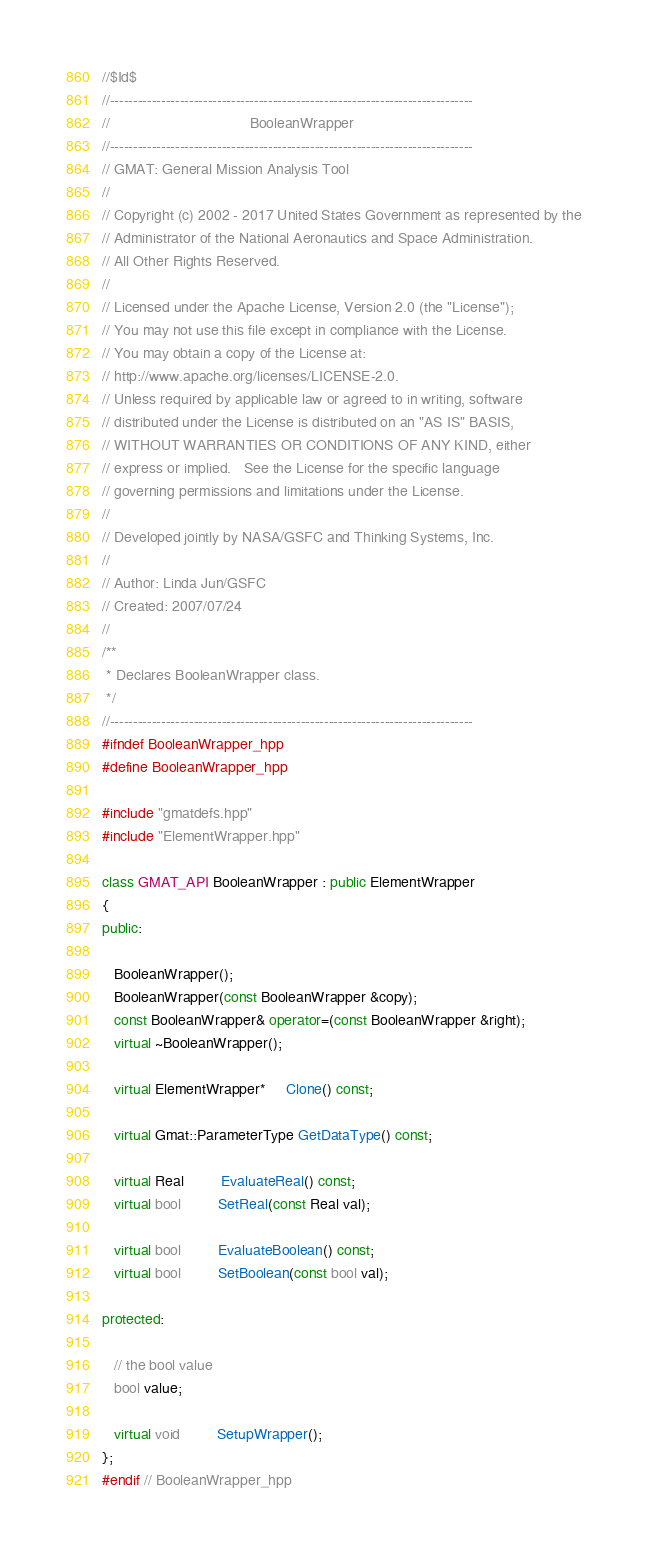Convert code to text. <code><loc_0><loc_0><loc_500><loc_500><_C++_>//$Id$
//------------------------------------------------------------------------------
//                                  BooleanWrapper
//------------------------------------------------------------------------------
// GMAT: General Mission Analysis Tool
//
// Copyright (c) 2002 - 2017 United States Government as represented by the
// Administrator of the National Aeronautics and Space Administration.
// All Other Rights Reserved.
//
// Licensed under the Apache License, Version 2.0 (the "License"); 
// You may not use this file except in compliance with the License. 
// You may obtain a copy of the License at:
// http://www.apache.org/licenses/LICENSE-2.0. 
// Unless required by applicable law or agreed to in writing, software
// distributed under the License is distributed on an "AS IS" BASIS,
// WITHOUT WARRANTIES OR CONDITIONS OF ANY KIND, either 
// express or implied.   See the License for the specific language
// governing permissions and limitations under the License.
//
// Developed jointly by NASA/GSFC and Thinking Systems, Inc. 
//
// Author: Linda Jun/GSFC
// Created: 2007/07/24
//
/**
 * Declares BooleanWrapper class.
 */
//------------------------------------------------------------------------------
#ifndef BooleanWrapper_hpp
#define BooleanWrapper_hpp

#include "gmatdefs.hpp"
#include "ElementWrapper.hpp"

class GMAT_API BooleanWrapper : public ElementWrapper
{
public:

   BooleanWrapper();
   BooleanWrapper(const BooleanWrapper &copy);
   const BooleanWrapper& operator=(const BooleanWrapper &right);
   virtual ~BooleanWrapper();
   
   virtual ElementWrapper*     Clone() const;

   virtual Gmat::ParameterType GetDataType() const;
   
   virtual Real         EvaluateReal() const;
   virtual bool         SetReal(const Real val);
   
   virtual bool         EvaluateBoolean() const;
   virtual bool         SetBoolean(const bool val);
   
protected:  

   // the bool value
   bool value;
   
   virtual void         SetupWrapper();
};
#endif // BooleanWrapper_hpp
</code> 